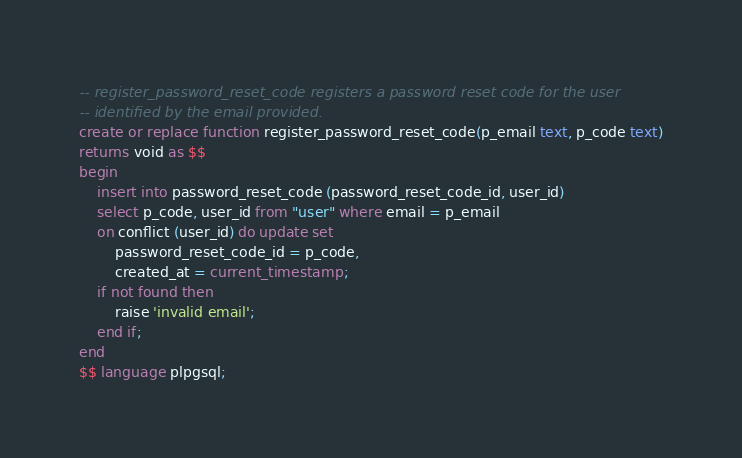Convert code to text. <code><loc_0><loc_0><loc_500><loc_500><_SQL_>-- register_password_reset_code registers a password reset code for the user
-- identified by the email provided.
create or replace function register_password_reset_code(p_email text, p_code text)
returns void as $$
begin
    insert into password_reset_code (password_reset_code_id, user_id)
    select p_code, user_id from "user" where email = p_email
    on conflict (user_id) do update set
        password_reset_code_id = p_code,
        created_at = current_timestamp;
    if not found then
        raise 'invalid email';
    end if;
end
$$ language plpgsql;
</code> 